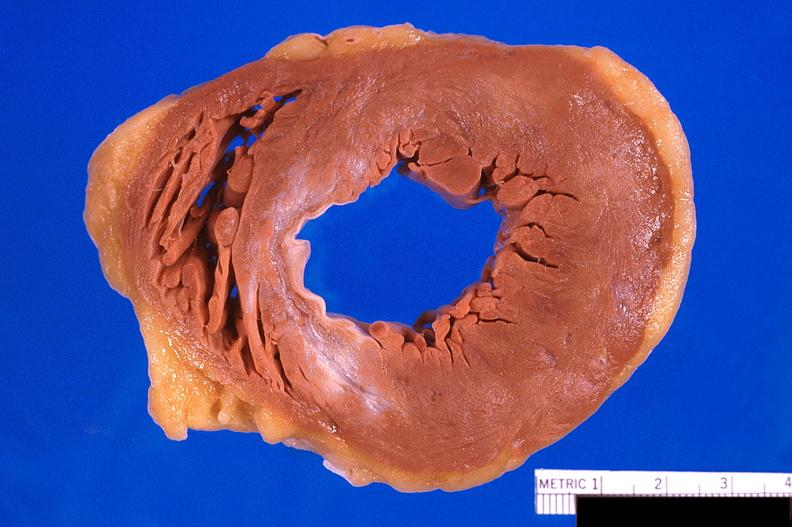s chest and abdomen slide present?
Answer the question using a single word or phrase. No 